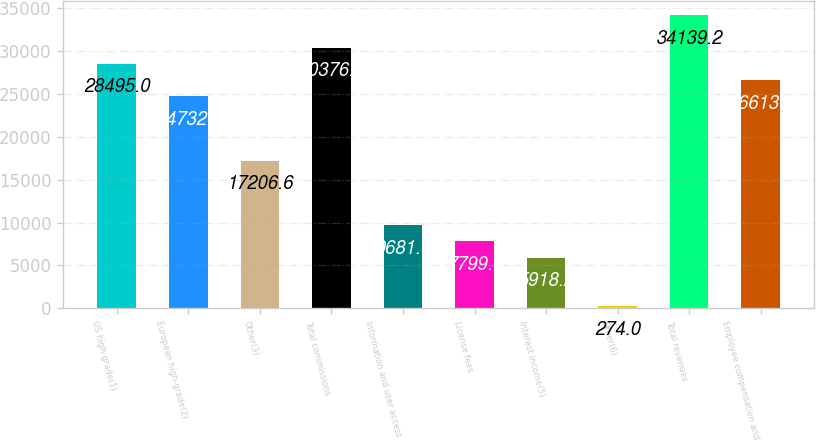<chart> <loc_0><loc_0><loc_500><loc_500><bar_chart><fcel>US high-grade(1)<fcel>European high-grade(2)<fcel>Other(3)<fcel>Total commissions<fcel>Information and user access<fcel>License fees<fcel>Interest income(5)<fcel>Other(6)<fcel>Total revenues<fcel>Employee compensation and<nl><fcel>28495<fcel>24732.2<fcel>17206.6<fcel>30376.4<fcel>9681<fcel>7799.6<fcel>5918.2<fcel>274<fcel>34139.2<fcel>26613.6<nl></chart> 